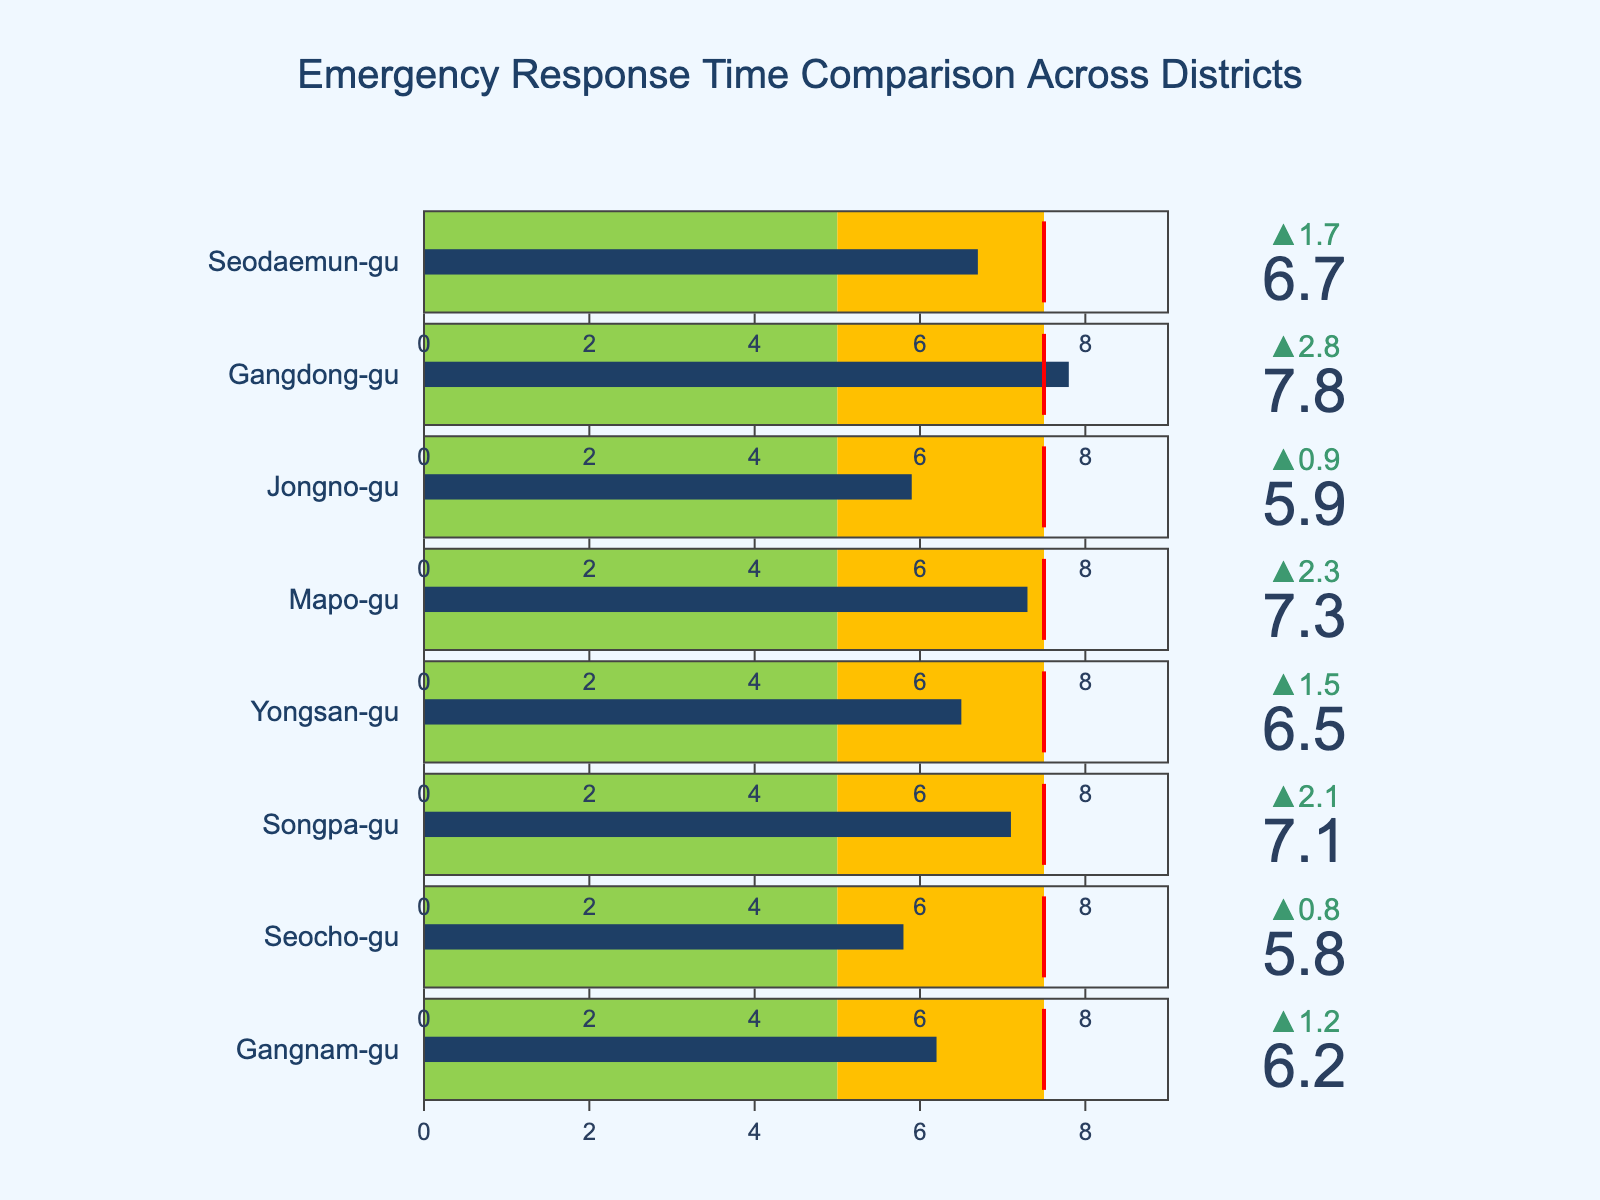what is the actual response time in Gangnam-gu? The figure shows a bullet chart for each district depicting actual response times. To find Gangnam-gu's response time, look for the bar labeled "Gangnam-gu".
Answer: 6.2 minutes Which district has the lowest actual response time? Compare the bars representing actual response times across all districts. The lowest value is in "Seocho-gu".
Answer: Seocho-gu What is the target response time for all districts? The target response time is indicated in the chart's annotation, which states "Target Response Time: 5 min".
Answer: 5 minutes Which district exceeds the national average by the largest margin? Subtract the national average (7.5 minutes) from the actual response times. The district with the largest positive difference is "Gangdong-gu" (7.8 - 7.5 = 0.3 minutes).
Answer: Gangdong-gu How many districts are meeting the target response time? Count the number of districts where the actual response time bar does not exceed the target response time of 5 minutes.
Answer: 0 What is the difference between actual and target response time for Yongsan-gu? Find Yongsan-gu's actual response time (6.5 minutes) and subtract the target response time (5 minutes).
Answer: 1.5 minutes Which district has the closest actual response time to the national average? Compare each district's actual response time with the national average (7.5 minutes). "Gangdong-gu" is closest with an actual response time of 7.8 minutes, differing by only 0.3 minutes.
Answer: Gangdong-gu Are there any districts with an actual response time less than the national average? Check each district's actual response time and compare it to the national average (7.5 minutes). Districts such as "Gangnam-gu", "Seocho-gu", "Songpa-gu", "Yongsan-gu", "Jongno-gu", and "Seodaemun-gu" have actual times less than the national average.
Answer: Yes What is the highest actual response time among the districts? Identify the district with the highest actual response time from the chart. "Gangdong-gu" has the highest actual response time of 7.8 minutes.
Answer: 7.8 minutes 